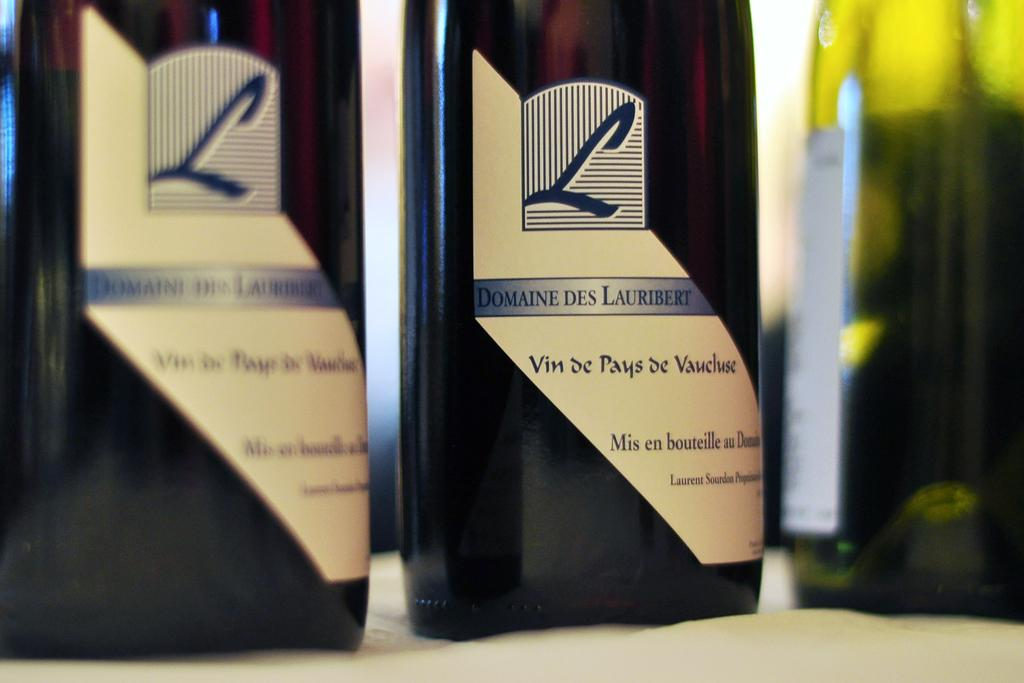Provide a one-sentence caption for the provided image. a wine bottle that says 'l domaine des lauribert' on it. 